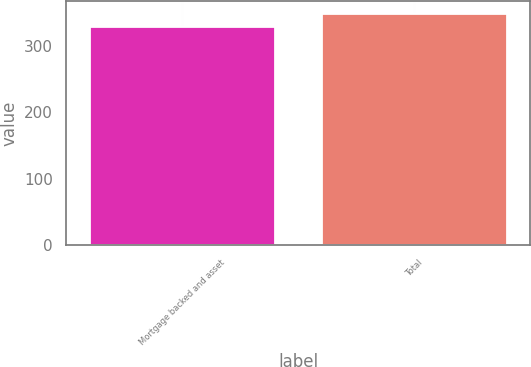Convert chart to OTSL. <chart><loc_0><loc_0><loc_500><loc_500><bar_chart><fcel>Mortgage backed and asset<fcel>Total<nl><fcel>331<fcel>350<nl></chart> 